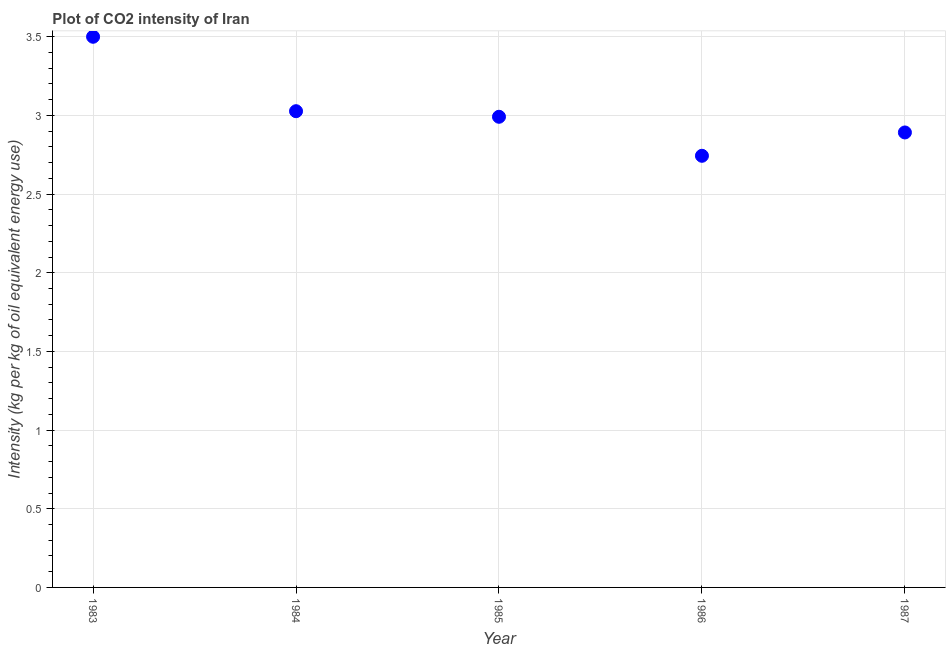What is the co2 intensity in 1986?
Your response must be concise. 2.74. Across all years, what is the maximum co2 intensity?
Offer a terse response. 3.5. Across all years, what is the minimum co2 intensity?
Ensure brevity in your answer.  2.74. What is the sum of the co2 intensity?
Your answer should be very brief. 15.15. What is the difference between the co2 intensity in 1983 and 1987?
Offer a terse response. 0.61. What is the average co2 intensity per year?
Make the answer very short. 3.03. What is the median co2 intensity?
Your response must be concise. 2.99. Do a majority of the years between 1984 and 1985 (inclusive) have co2 intensity greater than 0.5 kg?
Your answer should be compact. Yes. What is the ratio of the co2 intensity in 1985 to that in 1987?
Give a very brief answer. 1.03. What is the difference between the highest and the second highest co2 intensity?
Your response must be concise. 0.47. Is the sum of the co2 intensity in 1983 and 1984 greater than the maximum co2 intensity across all years?
Provide a short and direct response. Yes. What is the difference between the highest and the lowest co2 intensity?
Offer a very short reply. 0.76. In how many years, is the co2 intensity greater than the average co2 intensity taken over all years?
Your response must be concise. 1. How many years are there in the graph?
Offer a terse response. 5. What is the difference between two consecutive major ticks on the Y-axis?
Give a very brief answer. 0.5. Are the values on the major ticks of Y-axis written in scientific E-notation?
Offer a terse response. No. Does the graph contain grids?
Offer a very short reply. Yes. What is the title of the graph?
Your response must be concise. Plot of CO2 intensity of Iran. What is the label or title of the Y-axis?
Provide a short and direct response. Intensity (kg per kg of oil equivalent energy use). What is the Intensity (kg per kg of oil equivalent energy use) in 1983?
Ensure brevity in your answer.  3.5. What is the Intensity (kg per kg of oil equivalent energy use) in 1984?
Offer a very short reply. 3.03. What is the Intensity (kg per kg of oil equivalent energy use) in 1985?
Provide a short and direct response. 2.99. What is the Intensity (kg per kg of oil equivalent energy use) in 1986?
Provide a short and direct response. 2.74. What is the Intensity (kg per kg of oil equivalent energy use) in 1987?
Offer a terse response. 2.89. What is the difference between the Intensity (kg per kg of oil equivalent energy use) in 1983 and 1984?
Offer a terse response. 0.47. What is the difference between the Intensity (kg per kg of oil equivalent energy use) in 1983 and 1985?
Offer a very short reply. 0.51. What is the difference between the Intensity (kg per kg of oil equivalent energy use) in 1983 and 1986?
Provide a short and direct response. 0.76. What is the difference between the Intensity (kg per kg of oil equivalent energy use) in 1983 and 1987?
Keep it short and to the point. 0.61. What is the difference between the Intensity (kg per kg of oil equivalent energy use) in 1984 and 1985?
Offer a very short reply. 0.04. What is the difference between the Intensity (kg per kg of oil equivalent energy use) in 1984 and 1986?
Provide a succinct answer. 0.28. What is the difference between the Intensity (kg per kg of oil equivalent energy use) in 1984 and 1987?
Make the answer very short. 0.14. What is the difference between the Intensity (kg per kg of oil equivalent energy use) in 1985 and 1986?
Offer a terse response. 0.25. What is the difference between the Intensity (kg per kg of oil equivalent energy use) in 1985 and 1987?
Keep it short and to the point. 0.1. What is the difference between the Intensity (kg per kg of oil equivalent energy use) in 1986 and 1987?
Offer a terse response. -0.15. What is the ratio of the Intensity (kg per kg of oil equivalent energy use) in 1983 to that in 1984?
Ensure brevity in your answer.  1.16. What is the ratio of the Intensity (kg per kg of oil equivalent energy use) in 1983 to that in 1985?
Offer a terse response. 1.17. What is the ratio of the Intensity (kg per kg of oil equivalent energy use) in 1983 to that in 1986?
Your answer should be very brief. 1.28. What is the ratio of the Intensity (kg per kg of oil equivalent energy use) in 1983 to that in 1987?
Your response must be concise. 1.21. What is the ratio of the Intensity (kg per kg of oil equivalent energy use) in 1984 to that in 1986?
Your answer should be compact. 1.1. What is the ratio of the Intensity (kg per kg of oil equivalent energy use) in 1984 to that in 1987?
Give a very brief answer. 1.05. What is the ratio of the Intensity (kg per kg of oil equivalent energy use) in 1985 to that in 1986?
Your answer should be compact. 1.09. What is the ratio of the Intensity (kg per kg of oil equivalent energy use) in 1985 to that in 1987?
Give a very brief answer. 1.03. What is the ratio of the Intensity (kg per kg of oil equivalent energy use) in 1986 to that in 1987?
Provide a succinct answer. 0.95. 